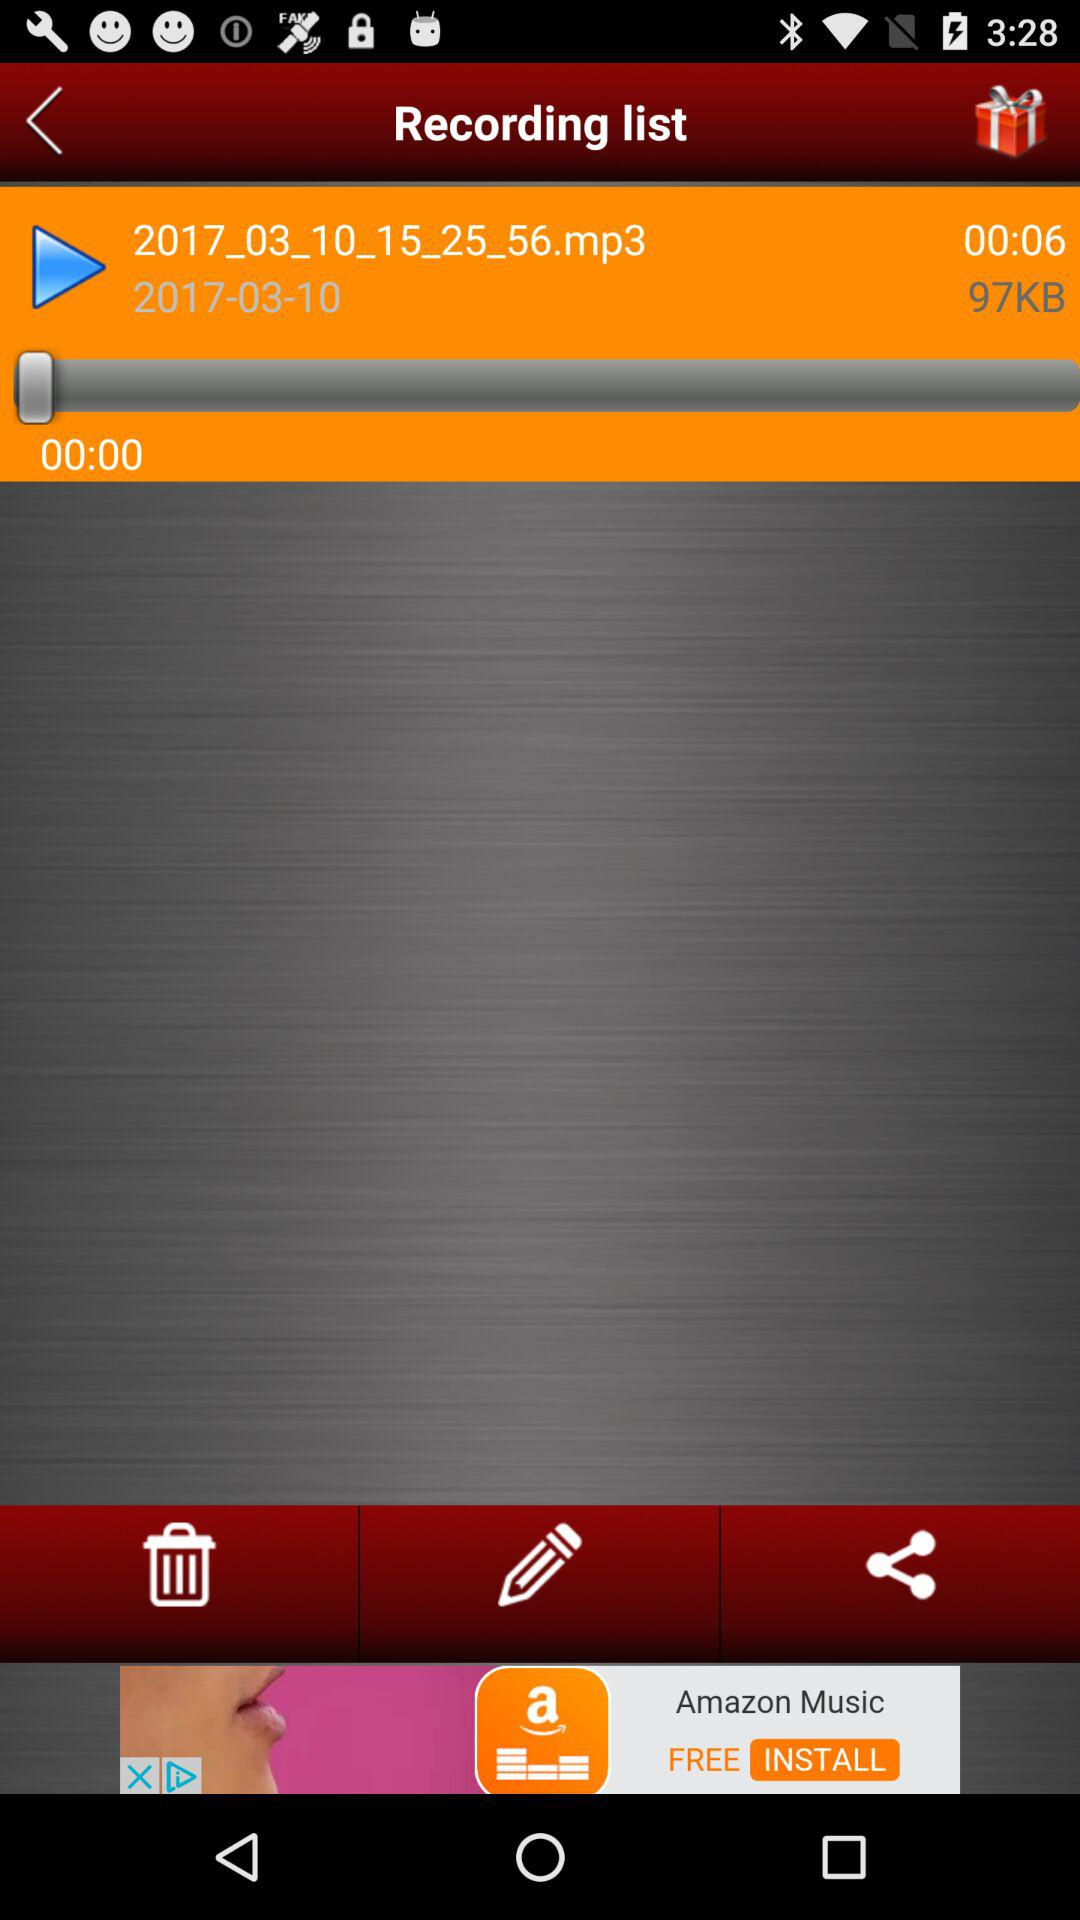How many seconds longer is the duration of the recording than the current playback time?
Answer the question using a single word or phrase. 6 